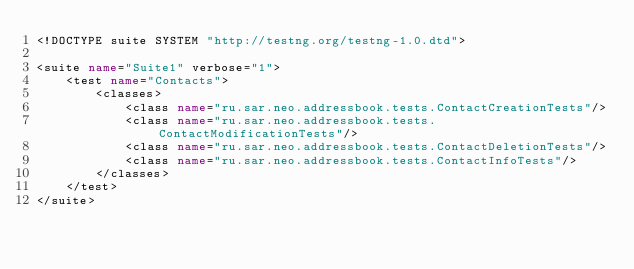Convert code to text. <code><loc_0><loc_0><loc_500><loc_500><_XML_><!DOCTYPE suite SYSTEM "http://testng.org/testng-1.0.dtd">

<suite name="Suite1" verbose="1">
    <test name="Contacts">
        <classes>
            <class name="ru.sar.neo.addressbook.tests.ContactCreationTests"/>
            <class name="ru.sar.neo.addressbook.tests.ContactModificationTests"/>
            <class name="ru.sar.neo.addressbook.tests.ContactDeletionTests"/>
            <class name="ru.sar.neo.addressbook.tests.ContactInfoTests"/>
        </classes>
    </test>
</suite></code> 